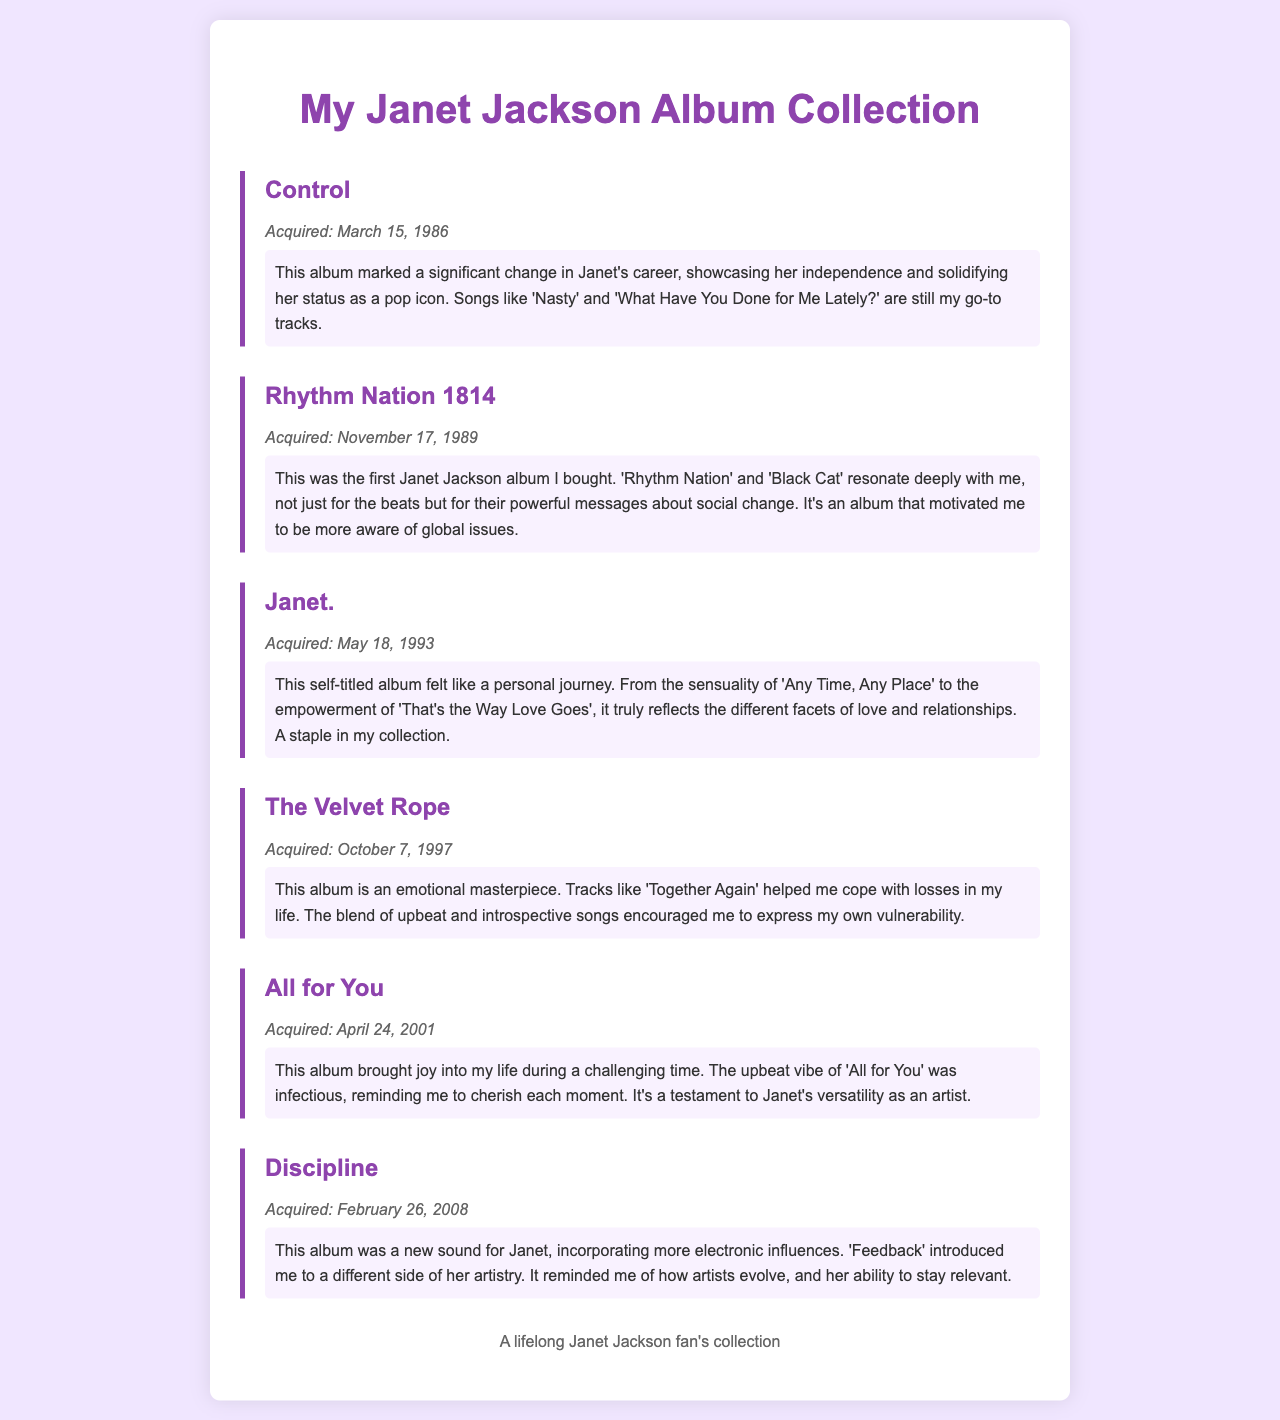What is the title of Janet Jackson's first album mentioned? The first album listed in the document is "Control".
Answer: Control When was the album "Rhythm Nation 1814" acquired? The document specifies that "Rhythm Nation 1814" was acquired on November 17, 1989.
Answer: November 17, 1989 What personal impact did the album "The Velvet Rope" have? The document notes that "The Velvet Rope" helped the author cope with losses in their life.
Answer: Cope with losses How many albums are listed in the document? By counting each album section, there are six albums mentioned in the document.
Answer: Six Which album was acquired the latest? The last album listed in the document is "Discipline".
Answer: Discipline What genre evolution is highlighted in "Discipline"? The document mentions that "Discipline" incorporated more electronic influences.
Answer: Electronic influences Which song from "Janet." reflects empowerment? The document states that "That's the Way Love Goes" reflects empowerment from the album "Janet.".
Answer: That's the Way Love Goes What color scheme is used for the album titles in the document? The album titles are colored in purple (#8e44ad) as indicated in the style section.
Answer: Purple What emotional theme is associated with "All for You"? The document notes that "All for You" brought joy during a challenging time.
Answer: Joy 